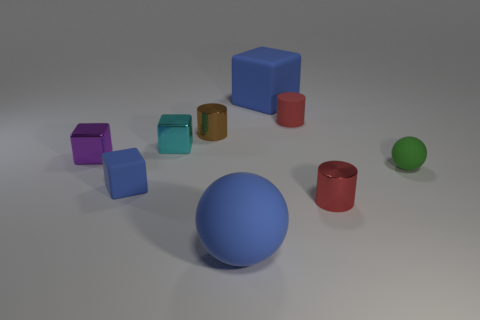Subtract all gray balls. How many red cylinders are left? 2 Subtract 2 blocks. How many blocks are left? 2 Subtract all small rubber cylinders. How many cylinders are left? 2 Subtract all purple cubes. How many cubes are left? 3 Add 1 cylinders. How many objects exist? 10 Subtract all blue cylinders. Subtract all blue blocks. How many cylinders are left? 3 Subtract all cylinders. How many objects are left? 6 Subtract all large blue matte balls. Subtract all cyan things. How many objects are left? 7 Add 8 big blue matte balls. How many big blue matte balls are left? 9 Add 4 big rubber blocks. How many big rubber blocks exist? 5 